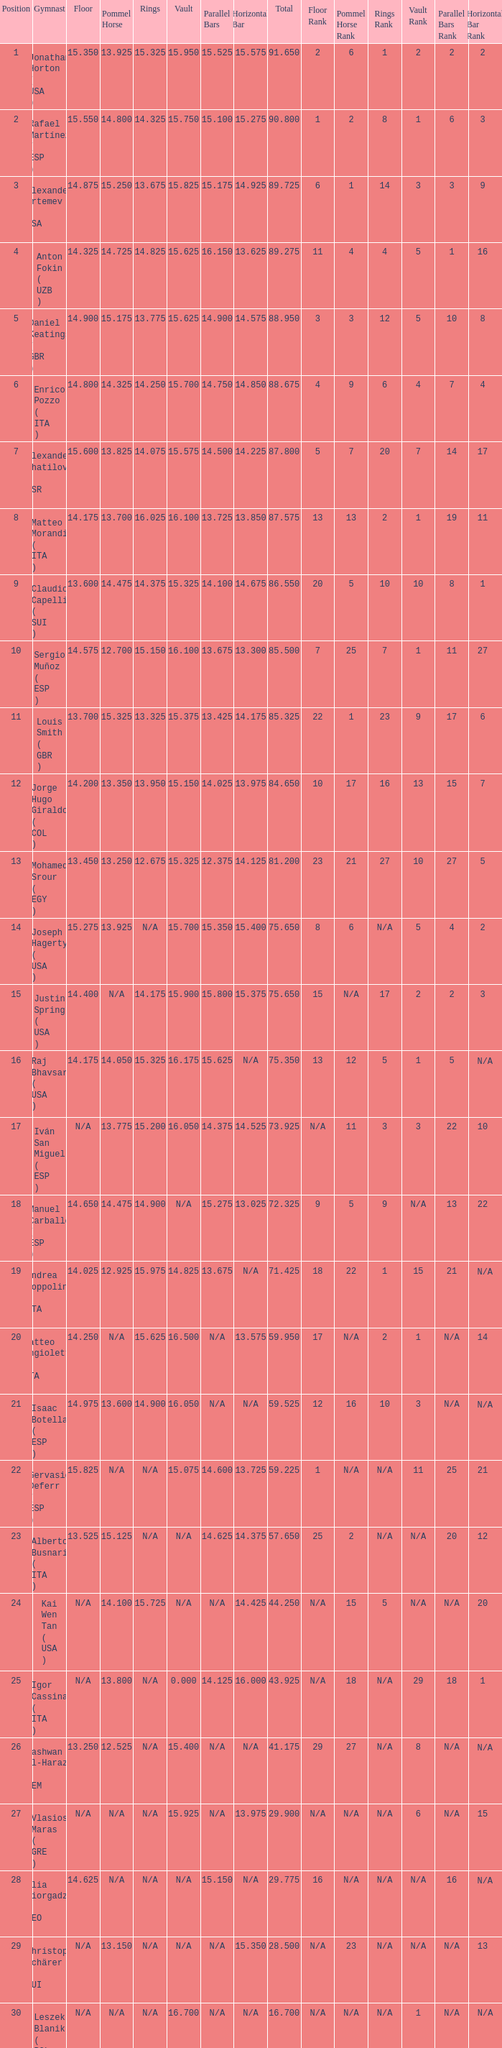If the horizontal bar is n/a and the floor is 14.175, what is the number for the parallel bars? 15.625. Parse the full table. {'header': ['Position', 'Gymnast', 'Floor', 'Pommel Horse', 'Rings', 'Vault', 'Parallel Bars', 'Horizontal Bar', 'Total', 'Floor Rank', 'Pommel Horse Rank', 'Rings Rank', 'Vault Rank', 'Parallel Bars Rank', 'Horizontal Bar Rank '], 'rows': [['1', 'Jonathan Horton ( USA )', '15.350', '13.925', '15.325', '15.950', '15.525', '15.575', '91.650', '2', '6', '1', '2', '2', '2 '], ['2', 'Rafael Martínez ( ESP )', '15.550', '14.800', '14.325', '15.750', '15.100', '15.275', '90.800', '1', '2', '8', '1', '6', '3 '], ['3', 'Alexander Artemev ( USA )', '14.875', '15.250', '13.675', '15.825', '15.175', '14.925', '89.725', '6', '1', '14', '3', '3', '9 '], ['4', 'Anton Fokin ( UZB )', '14.325', '14.725', '14.825', '15.625', '16.150', '13.625', '89.275', '11', '4', '4', '5', '1', '16 '], ['5', 'Daniel Keatings ( GBR )', '14.900', '15.175', '13.775', '15.625', '14.900', '14.575', '88.950', '3', '3', '12', '5', '10', '8 '], ['6', 'Enrico Pozzo ( ITA )', '14.800', '14.325', '14.250', '15.700', '14.750', '14.850', '88.675', '4', '9', '6', '4', '7', '4 '], ['7', 'Alexander Shatilov ( ISR )', '15.600', '13.825', '14.075', '15.575', '14.500', '14.225', '87.800', '5', '7', '20', '7', '14', '17 '], ['8', 'Matteo Morandi ( ITA )', '14.175', '13.700', '16.025', '16.100', '13.725', '13.850', '87.575', '13', '13', '2', '1', '19', '11 '], ['9', 'Claudio Capelli ( SUI )', '13.600', '14.475', '14.375', '15.325', '14.100', '14.675', '86.550', '20', '5', '10', '10', '8', '1 '], ['10', 'Sergio Muñoz ( ESP )', '14.575', '12.700', '15.150', '16.100', '13.675', '13.300', '85.500', '7', '25', '7', '1', '11', '27 '], ['11', 'Louis Smith ( GBR )', '13.700', '15.325', '13.325', '15.375', '13.425', '14.175', '85.325', '22', '1', '23', '9', '17', '6 '], ['12', 'Jorge Hugo Giraldo ( COL )', '14.200', '13.350', '13.950', '15.150', '14.025', '13.975', '84.650', '10', '17', '16', '13', '15', '7 '], ['13', 'Mohamed Srour ( EGY )', '13.450', '13.250', '12.675', '15.325', '12.375', '14.125', '81.200', '23', '21', '27', '10', '27', '5 '], ['14', 'Joseph Hagerty ( USA )', '15.275', '13.925', 'N/A', '15.700', '15.350', '15.400', '75.650', '8', '6', 'N/A', '5', '4', '2 '], ['15', 'Justin Spring ( USA )', '14.400', 'N/A', '14.175', '15.900', '15.800', '15.375', '75.650', '15', 'N/A', '17', '2', '2', '3 '], ['16', 'Raj Bhavsar ( USA )', '14.175', '14.050', '15.325', '16.175', '15.625', 'N/A', '75.350', '13', '12', '5', '1', '5', 'N/A '], ['17', 'Iván San Miguel ( ESP )', 'N/A', '13.775', '15.200', '16.050', '14.375', '14.525', '73.925', 'N/A', '11', '3', '3', '22', '10 '], ['18', 'Manuel Carballo ( ESP )', '14.650', '14.475', '14.900', 'N/A', '15.275', '13.025', '72.325', '9', '5', '9', 'N/A', '13', '22 '], ['19', 'Andrea Coppolino ( ITA )', '14.025', '12.925', '15.975', '14.825', '13.675', 'N/A', '71.425', '18', '22', '1', '15', '21', 'N/A '], ['20', 'Matteo Angioletti ( ITA )', '14.250', 'N/A', '15.625', '16.500', 'N/A', '13.575', '59.950', '17', 'N/A', '2', '1', 'N/A', '14 '], ['21', 'Isaac Botella ( ESP )', '14.975', '13.600', '14.900', '16.050', 'N/A', 'N/A', '59.525', '12', '16', '10', '3', 'N/A', 'N/A '], ['22', 'Gervasio Deferr ( ESP )', '15.825', 'N/A', 'N/A', '15.075', '14.600', '13.725', '59.225', '1', 'N/A', 'N/A', '11', '25', '21 '], ['23', 'Alberto Busnari ( ITA )', '13.525', '15.125', 'N/A', 'N/A', '14.625', '14.375', '57.650', '25', '2', 'N/A', 'N/A', '20', '12 '], ['24', 'Kai Wen Tan ( USA )', 'N/A', '14.100', '15.725', 'N/A', 'N/A', '14.425', '44.250', 'N/A', '15', '5', 'N/A', 'N/A', '20 '], ['25', 'Igor Cassina ( ITA )', 'N/A', '13.800', 'N/A', '0.000', '14.125', '16.000', '43.925', 'N/A', '18', 'N/A', '29', '18', '1 '], ['26', 'Nashwan Al-Harazi ( YEM )', '13.250', '12.525', 'N/A', '15.400', 'N/A', 'N/A', '41.175', '29', '27', 'N/A', '8', 'N/A', 'N/A '], ['27', 'Vlasios Maras ( GRE )', 'N/A', 'N/A', 'N/A', '15.925', 'N/A', '13.975', '29.900', 'N/A', 'N/A', 'N/A', '6', 'N/A', '15 '], ['28', 'Ilia Giorgadze ( GEO )', '14.625', 'N/A', 'N/A', 'N/A', '15.150', 'N/A', '29.775', '16', 'N/A', 'N/A', 'N/A', '16', 'N/A '], ['29', 'Christoph Schärer ( SUI )', 'N/A', '13.150', 'N/A', 'N/A', 'N/A', '15.350', '28.500', 'N/A', '23', 'N/A', 'N/A', 'N/A', '13 '], ['30', 'Leszek Blanik ( POL )', 'N/A', 'N/A', 'N/A', '16.700', 'N/A', 'N/A', '16.700', 'N/A', 'N/A', 'N/A', '1', 'N/A', 'N/A']]} 